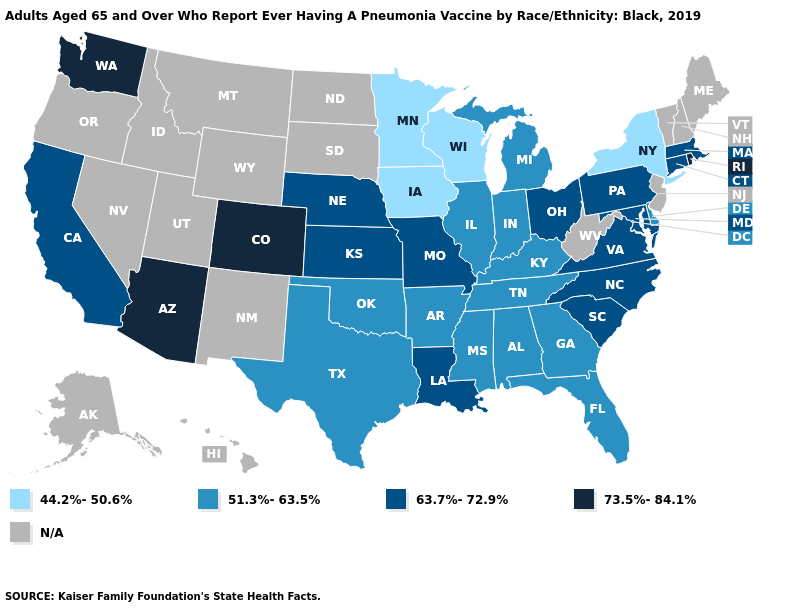Name the states that have a value in the range N/A?
Keep it brief. Alaska, Hawaii, Idaho, Maine, Montana, Nevada, New Hampshire, New Jersey, New Mexico, North Dakota, Oregon, South Dakota, Utah, Vermont, West Virginia, Wyoming. Name the states that have a value in the range 63.7%-72.9%?
Short answer required. California, Connecticut, Kansas, Louisiana, Maryland, Massachusetts, Missouri, Nebraska, North Carolina, Ohio, Pennsylvania, South Carolina, Virginia. How many symbols are there in the legend?
Keep it brief. 5. What is the value of South Dakota?
Write a very short answer. N/A. What is the value of Louisiana?
Answer briefly. 63.7%-72.9%. Among the states that border Louisiana , which have the highest value?
Give a very brief answer. Arkansas, Mississippi, Texas. Does California have the lowest value in the West?
Answer briefly. Yes. What is the value of New York?
Write a very short answer. 44.2%-50.6%. Name the states that have a value in the range 63.7%-72.9%?
Concise answer only. California, Connecticut, Kansas, Louisiana, Maryland, Massachusetts, Missouri, Nebraska, North Carolina, Ohio, Pennsylvania, South Carolina, Virginia. What is the highest value in the USA?
Keep it brief. 73.5%-84.1%. Name the states that have a value in the range 51.3%-63.5%?
Concise answer only. Alabama, Arkansas, Delaware, Florida, Georgia, Illinois, Indiana, Kentucky, Michigan, Mississippi, Oklahoma, Tennessee, Texas. What is the lowest value in the Northeast?
Concise answer only. 44.2%-50.6%. Does the first symbol in the legend represent the smallest category?
Keep it brief. Yes. What is the value of Alabama?
Short answer required. 51.3%-63.5%. 